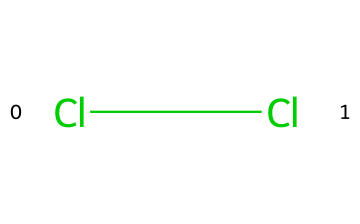What is the chemical formula of the substance shown? The SMILES representation "Cl-Cl" indicates that the substance consists of two chlorine atoms bonded together, which corresponds to the chemical formula Cl2 for chlorine gas.
Answer: Cl2 How many bonds are present in this molecule? The representation "Cl-Cl" shows a single line connecting two chlorine atoms, indicating that there is one covalent bond between them.
Answer: 1 What type of substance is represented in the SMILES? The diatomic structure of "Cl-Cl" indicates that this molecule is a gas at room temperature and specifically represents chlorine gas.
Answer: gas Are chlorine gas molecules polar or nonpolar? The "Cl-Cl" structure shows that the two chlorine atoms are identical, resulting in an equal sharing of electrons, making the molecule nonpolar.
Answer: nonpolar In terms of the arrangement, how many atoms make up one molecule of chlorine gas? The SMILES "Cl-Cl" indicates two chlorine atoms are covalently bonded, so one molecule of chlorine gas consists of exactly two atoms.
Answer: 2 How would you classify the bonding in chlorine gas? The single connection represented by "Cl-Cl" indicates a covalent bond between the two chlorine atoms, categorizing the bonding type as covalent.
Answer: covalent 